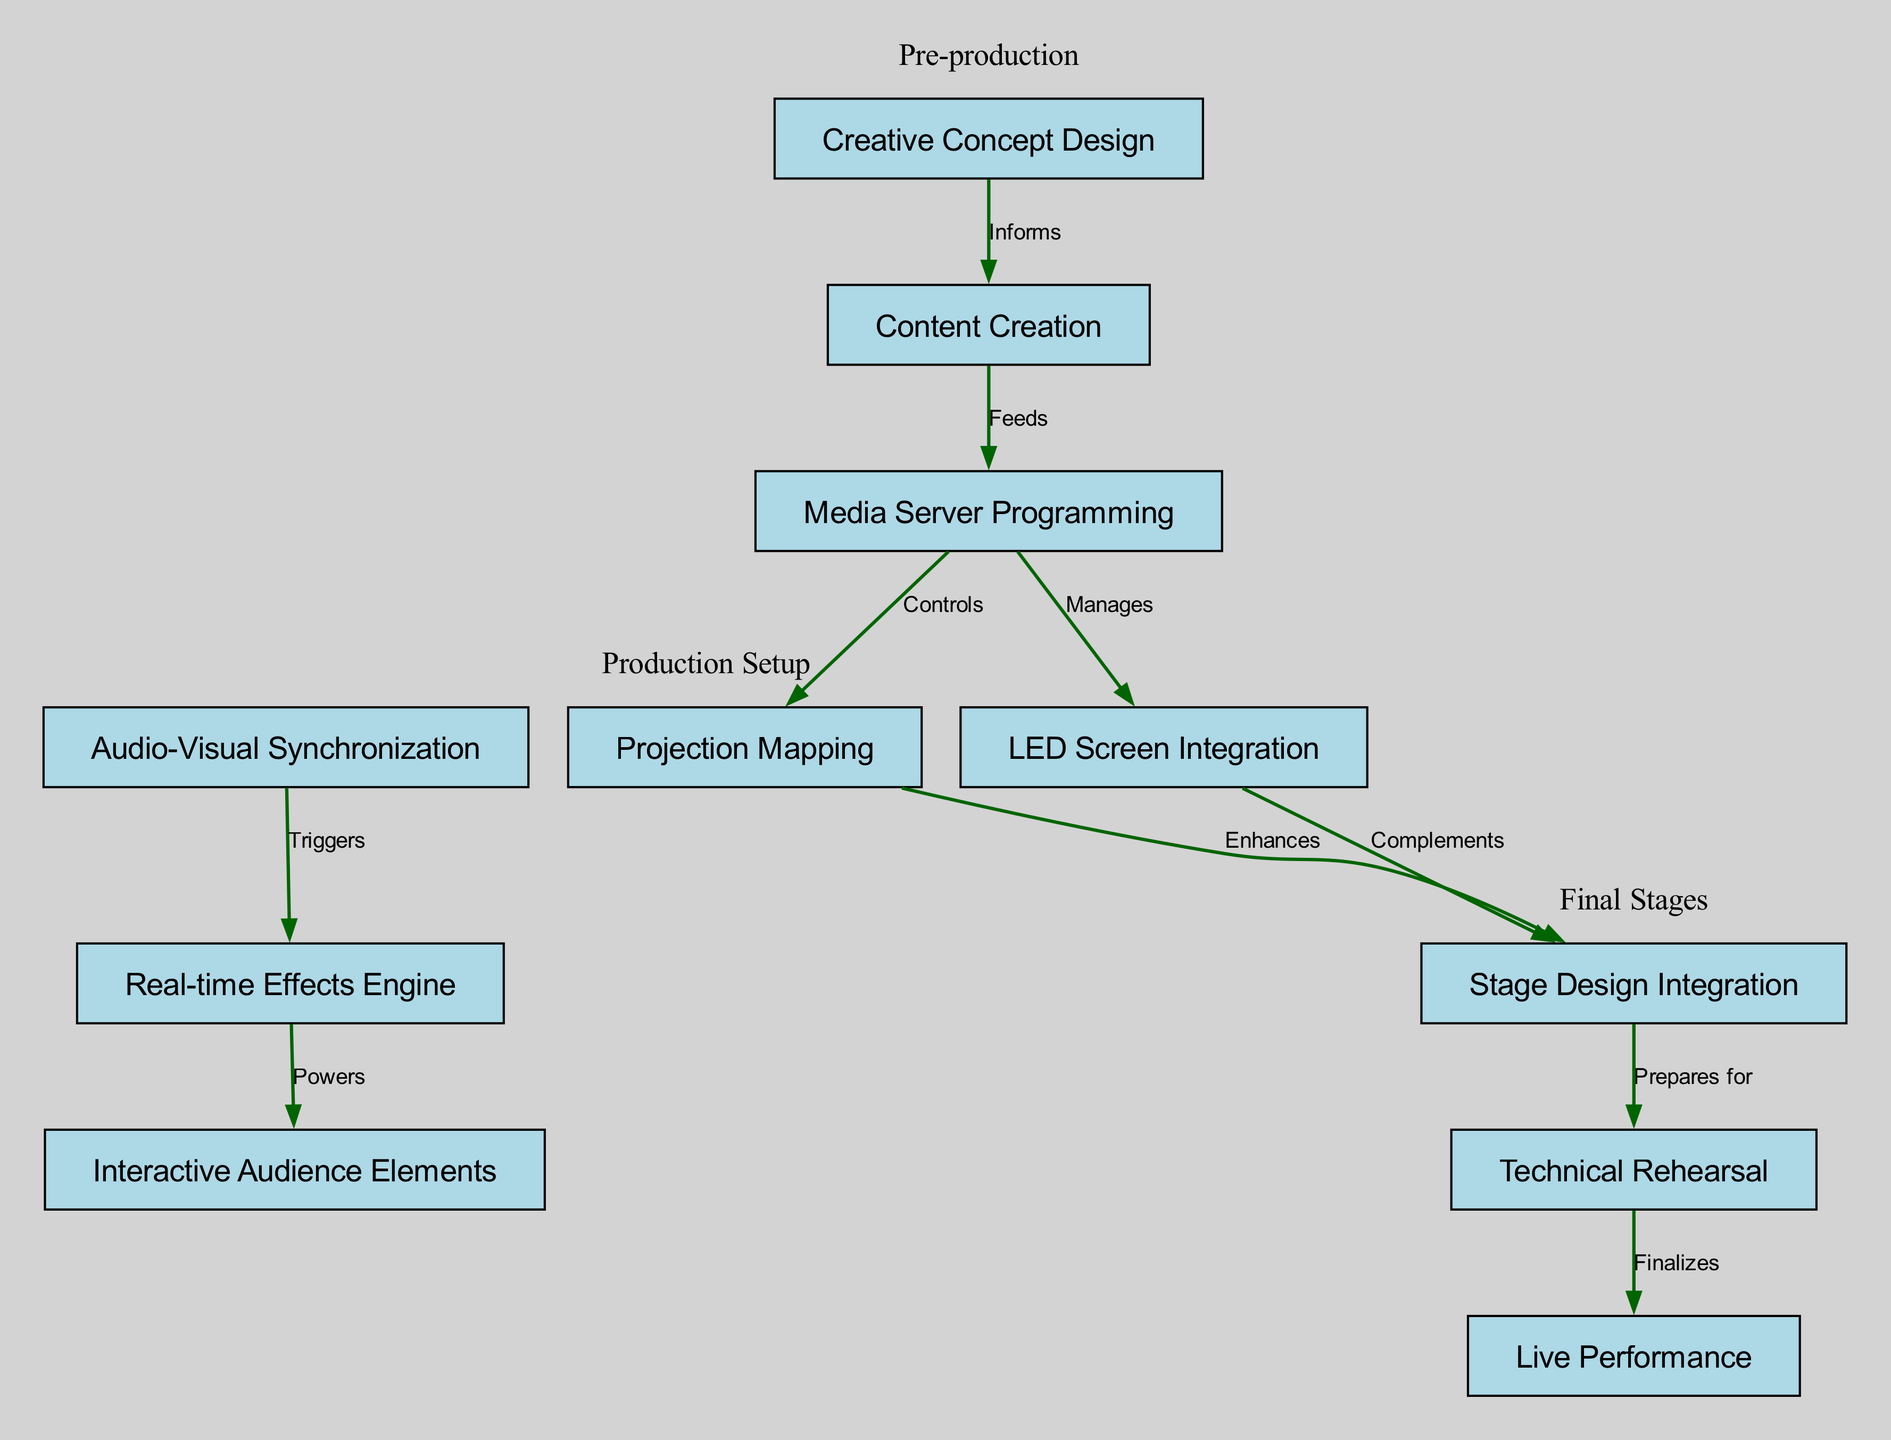What is the first node in the workflow? The first node is "Creative Concept Design", which is positioned at the top of the diagram and serves as the starting point for the entire multimedia integration workflow.
Answer: Creative Concept Design How many total nodes are in the diagram? The diagram contains 11 distinct nodes, each representing a unique task or component within the multimedia integration workflow.
Answer: 11 Which node is connected to "Projection Mapping"? "Media Server Programming" is directly connected to "Projection Mapping" as it "Controls" this process according to the edge description.
Answer: Media Server Programming What role does "Audio-Visual Synchronization" play in relation to the "Real-time Effects Engine"? "Audio-Visual Synchronization" "Triggers" the "Real-time Effects Engine", indicating that it activates or sets off the effects engine when audio and visuals are integrated.
Answer: Triggers Which two nodes are enhanced by "Projection Mapping"? "Stage Design Integration" is enhanced by "Projection Mapping", indicating that the projection mapping process adds value or improves the stage design.
Answer: Stage Design Integration What does the "Technical Rehearsal" prepare for? The "Technical Rehearsal" prepares for the "Live Performance", signifying that it is a crucial step that finalizes the aspects needed for the actual event.
Answer: Live Performance How does "Content Creation" relate to "Media Server Programming"? "Content Creation" "Feeds" into "Media Server Programming", suggesting that content developed during this phase is inputted into the media server programming.
Answer: Feeds What is the last step before the "Live Performance"? The last step before the "Live Performance" is the "Technical Rehearsal", which is positioned just prior to the final performance in the workflow.
Answer: Technical Rehearsal How are "LED Screen Integration" and "Stage Design Integration" connected? "LED Screen Integration" "Complements" "Stage Design Integration", indicating that the integration of LED screens enhances the overall stage design.
Answer: Complements Which component powers the "Interactive Audience Elements"? The "Real-time Effects Engine" powers the "Interactive Audience Elements", demonstrating its role in creating dynamic features that engage the audience during the performance.
Answer: Powers 